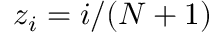Convert formula to latex. <formula><loc_0><loc_0><loc_500><loc_500>z _ { i } = i / ( N + 1 )</formula> 